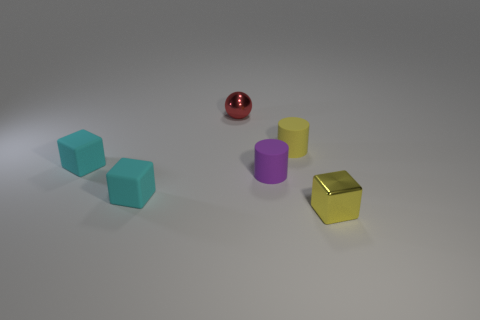The thing that is both in front of the purple rubber object and to the left of the purple matte object is what color?
Make the answer very short. Cyan. How many purple cylinders are there?
Ensure brevity in your answer.  1. Are there any other things that are the same size as the yellow matte object?
Ensure brevity in your answer.  Yes. Is the sphere made of the same material as the purple thing?
Make the answer very short. No. There is a object that is right of the small yellow rubber cylinder; is it the same size as the matte object that is on the right side of the small purple rubber cylinder?
Your answer should be compact. Yes. Are there fewer large green cylinders than spheres?
Provide a succinct answer. Yes. What number of matte objects are yellow blocks or large purple cubes?
Ensure brevity in your answer.  0. There is a metal object that is behind the purple object; are there any red metal objects on the left side of it?
Your response must be concise. No. Does the block that is right of the red metal thing have the same material as the small purple thing?
Ensure brevity in your answer.  No. How many other objects are the same color as the ball?
Make the answer very short. 0. 